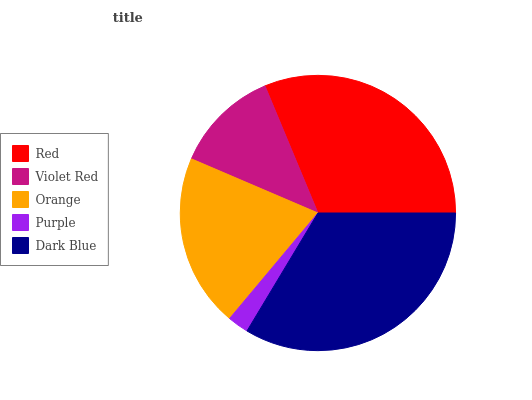Is Purple the minimum?
Answer yes or no. Yes. Is Dark Blue the maximum?
Answer yes or no. Yes. Is Violet Red the minimum?
Answer yes or no. No. Is Violet Red the maximum?
Answer yes or no. No. Is Red greater than Violet Red?
Answer yes or no. Yes. Is Violet Red less than Red?
Answer yes or no. Yes. Is Violet Red greater than Red?
Answer yes or no. No. Is Red less than Violet Red?
Answer yes or no. No. Is Orange the high median?
Answer yes or no. Yes. Is Orange the low median?
Answer yes or no. Yes. Is Violet Red the high median?
Answer yes or no. No. Is Dark Blue the low median?
Answer yes or no. No. 